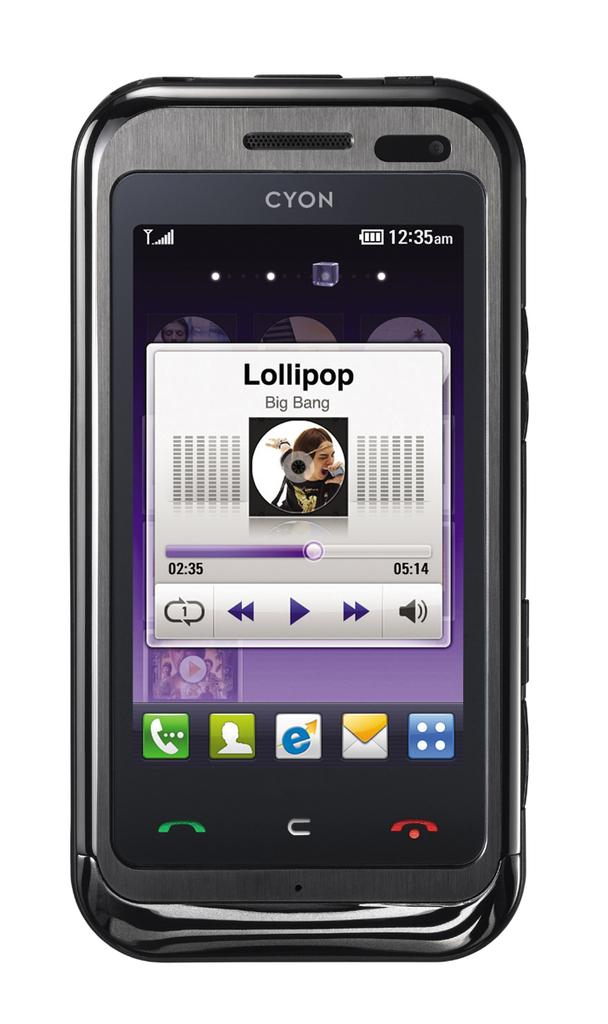<image>
Describe the image concisely. Lollipop by Big Bang is the name of the song playing on this CYON phone. 